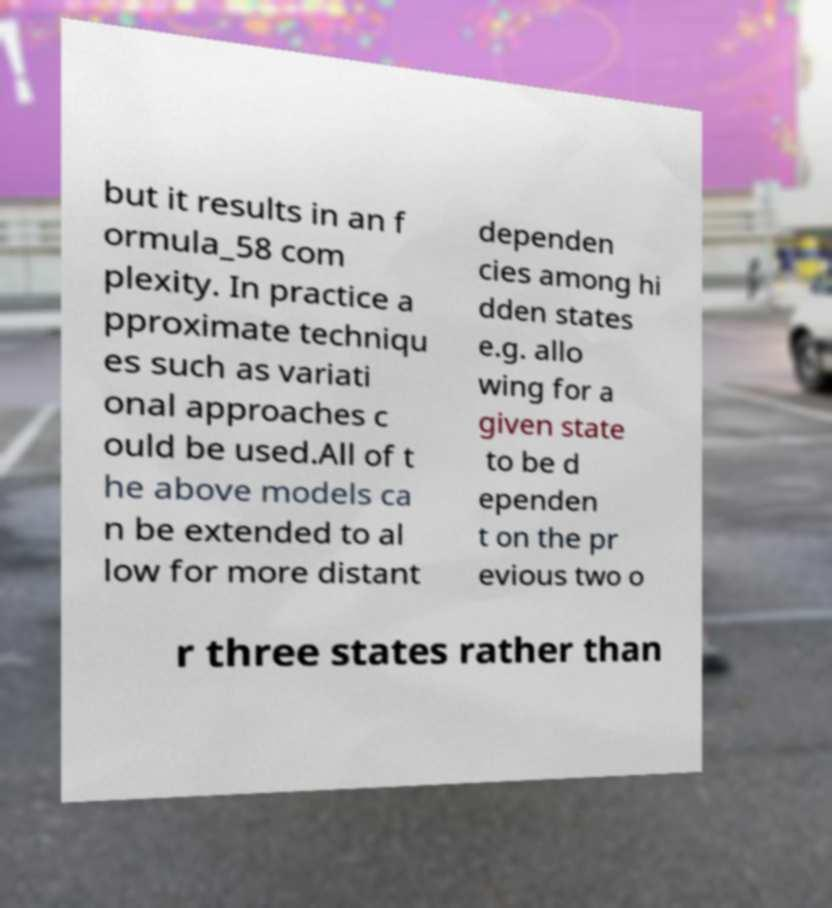Please read and relay the text visible in this image. What does it say? but it results in an f ormula_58 com plexity. In practice a pproximate techniqu es such as variati onal approaches c ould be used.All of t he above models ca n be extended to al low for more distant dependen cies among hi dden states e.g. allo wing for a given state to be d ependen t on the pr evious two o r three states rather than 